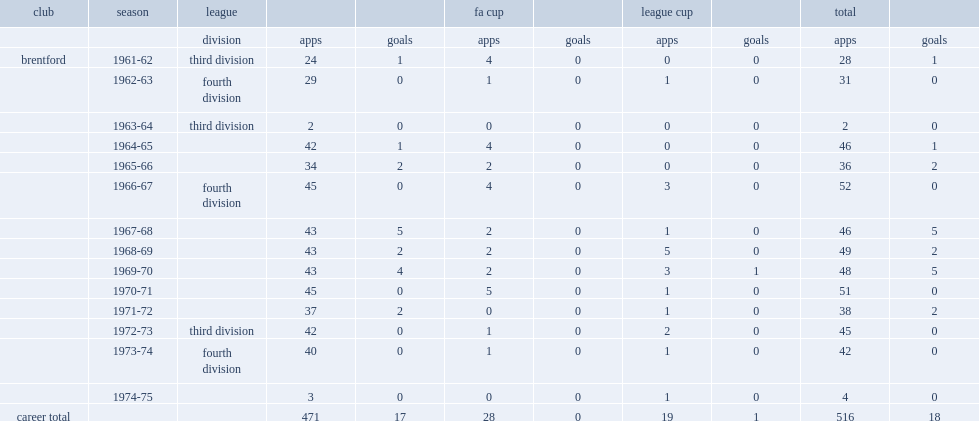How many appearances did peter gelson make for brentford? 516.0. 